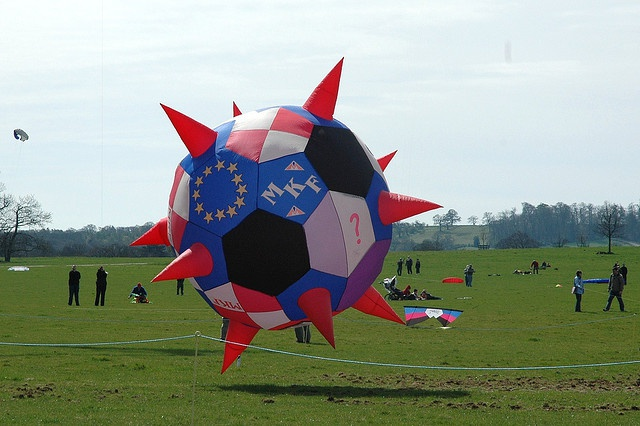Describe the objects in this image and their specific colors. I can see kite in white, black, navy, brown, and gray tones, people in white, darkgreen, and black tones, kite in white, black, lightgray, salmon, and violet tones, people in white, black, gray, and darkgreen tones, and people in white, black, and darkgreen tones in this image. 